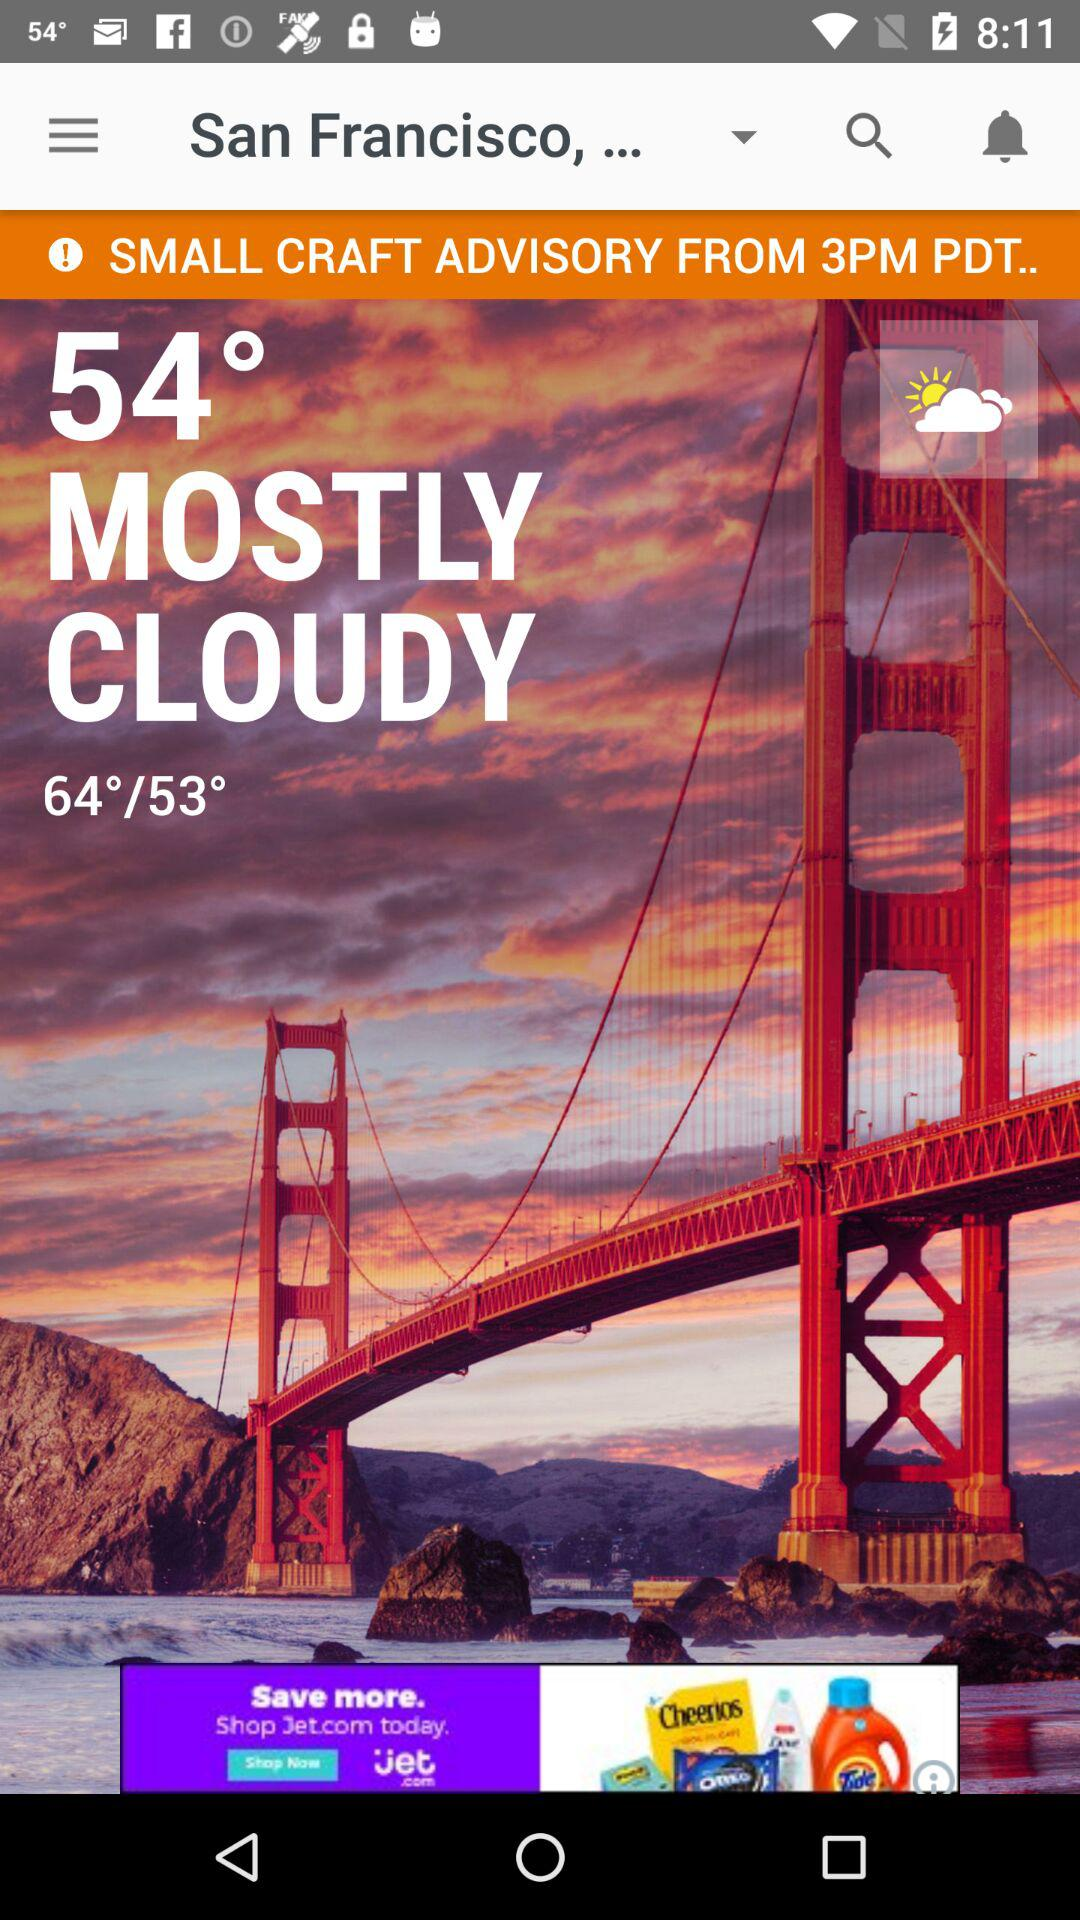What is the current temperature? The current temperature is 54°. 